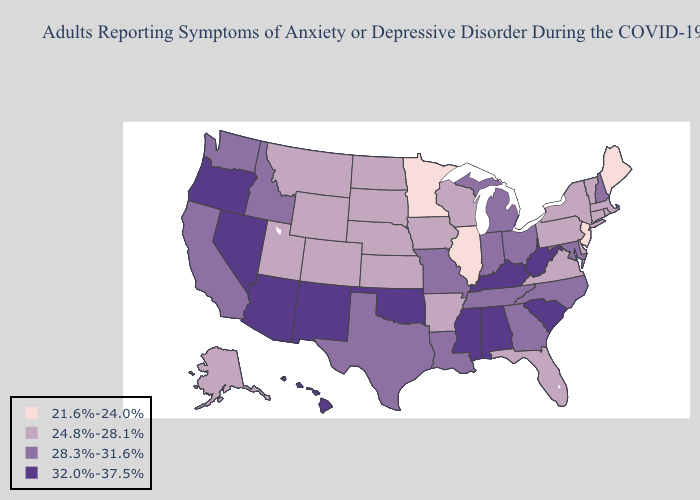Which states have the lowest value in the South?
Be succinct. Arkansas, Delaware, Florida, Virginia. Does Missouri have the same value as Pennsylvania?
Give a very brief answer. No. Does Mississippi have the highest value in the USA?
Answer briefly. Yes. What is the value of Georgia?
Quick response, please. 28.3%-31.6%. Among the states that border Maryland , does Pennsylvania have the lowest value?
Be succinct. Yes. Does Ohio have the lowest value in the USA?
Be succinct. No. Name the states that have a value in the range 21.6%-24.0%?
Answer briefly. Illinois, Maine, Minnesota, New Jersey. Which states have the lowest value in the Northeast?
Be succinct. Maine, New Jersey. Is the legend a continuous bar?
Answer briefly. No. Name the states that have a value in the range 24.8%-28.1%?
Quick response, please. Alaska, Arkansas, Colorado, Connecticut, Delaware, Florida, Iowa, Kansas, Massachusetts, Montana, Nebraska, New York, North Dakota, Pennsylvania, Rhode Island, South Dakota, Utah, Vermont, Virginia, Wisconsin, Wyoming. Among the states that border Kentucky , which have the lowest value?
Be succinct. Illinois. Name the states that have a value in the range 24.8%-28.1%?
Give a very brief answer. Alaska, Arkansas, Colorado, Connecticut, Delaware, Florida, Iowa, Kansas, Massachusetts, Montana, Nebraska, New York, North Dakota, Pennsylvania, Rhode Island, South Dakota, Utah, Vermont, Virginia, Wisconsin, Wyoming. Does Washington have the same value as South Dakota?
Give a very brief answer. No. Which states hav the highest value in the MidWest?
Write a very short answer. Indiana, Michigan, Missouri, Ohio. 